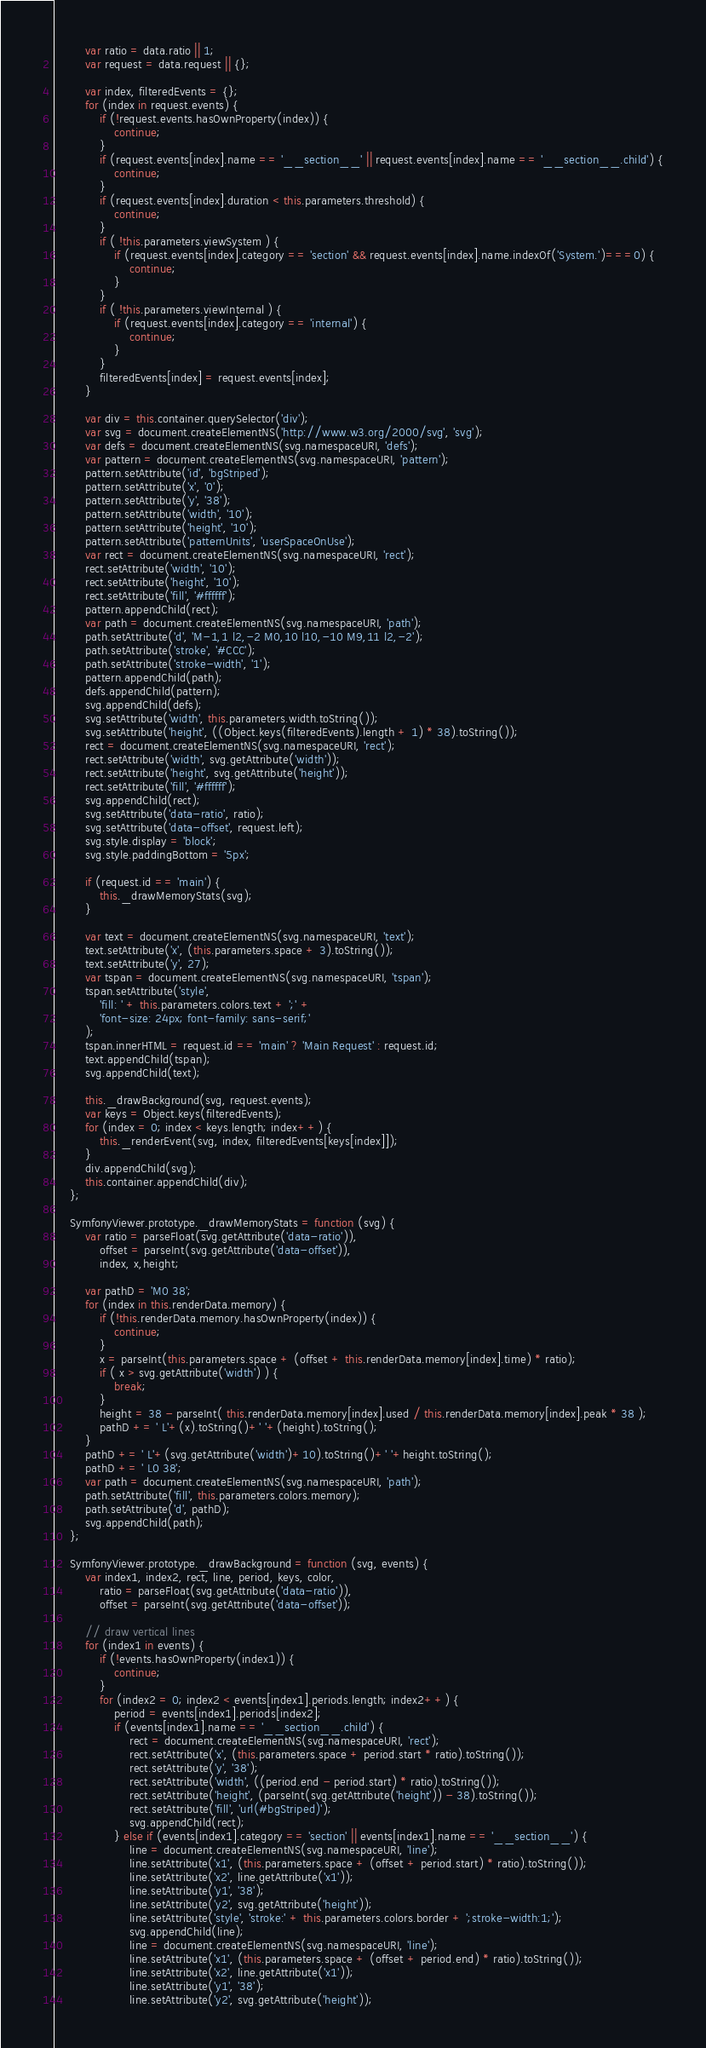Convert code to text. <code><loc_0><loc_0><loc_500><loc_500><_JavaScript_>        var ratio = data.ratio || 1;
        var request = data.request || {};

        var index, filteredEvents = {};
        for (index in request.events) {
            if (!request.events.hasOwnProperty(index)) {
                continue;
            }
            if (request.events[index].name == '__section__' || request.events[index].name == '__section__.child') {
                continue;
            }
            if (request.events[index].duration < this.parameters.threshold) {
                continue;
            }
            if ( !this.parameters.viewSystem ) {
                if (request.events[index].category == 'section' && request.events[index].name.indexOf('System.')===0) {
                    continue;
                }
            }
            if ( !this.parameters.viewInternal ) {
                if (request.events[index].category == 'internal') {
                    continue;
                }
            }
            filteredEvents[index] = request.events[index];
        }

        var div = this.container.querySelector('div');
        var svg = document.createElementNS('http://www.w3.org/2000/svg', 'svg');
        var defs = document.createElementNS(svg.namespaceURI, 'defs');
        var pattern = document.createElementNS(svg.namespaceURI, 'pattern');
        pattern.setAttribute('id', 'bgStriped');
        pattern.setAttribute('x', '0');
        pattern.setAttribute('y', '38');
        pattern.setAttribute('width', '10');
        pattern.setAttribute('height', '10');
        pattern.setAttribute('patternUnits', 'userSpaceOnUse');
        var rect = document.createElementNS(svg.namespaceURI, 'rect');
        rect.setAttribute('width', '10');
        rect.setAttribute('height', '10');
        rect.setAttribute('fill', '#ffffff');
        pattern.appendChild(rect);
        var path = document.createElementNS(svg.namespaceURI, 'path');
        path.setAttribute('d', 'M-1,1 l2,-2 M0,10 l10,-10 M9,11 l2,-2');
        path.setAttribute('stroke', '#CCC');
        path.setAttribute('stroke-width', '1');
        pattern.appendChild(path);
        defs.appendChild(pattern);
        svg.appendChild(defs);
        svg.setAttribute('width', this.parameters.width.toString());
        svg.setAttribute('height', ((Object.keys(filteredEvents).length + 1) * 38).toString());
        rect = document.createElementNS(svg.namespaceURI, 'rect');
        rect.setAttribute('width', svg.getAttribute('width'));
        rect.setAttribute('height', svg.getAttribute('height'));
        rect.setAttribute('fill', '#ffffff');
        svg.appendChild(rect);
        svg.setAttribute('data-ratio', ratio);
        svg.setAttribute('data-offset', request.left);
        svg.style.display = 'block';
        svg.style.paddingBottom = '5px';

        if (request.id == 'main') {
            this._drawMemoryStats(svg);
        }

        var text = document.createElementNS(svg.namespaceURI, 'text');
        text.setAttribute('x', (this.parameters.space + 3).toString());
        text.setAttribute('y', 27);
        var tspan = document.createElementNS(svg.namespaceURI, 'tspan');
        tspan.setAttribute('style',
            'fill: ' + this.parameters.colors.text + ';' +
            'font-size: 24px; font-family: sans-serif;'
        );
        tspan.innerHTML = request.id == 'main' ? 'Main Request' : request.id;
        text.appendChild(tspan);
        svg.appendChild(text);

        this._drawBackground(svg, request.events);
        var keys = Object.keys(filteredEvents);
        for (index = 0; index < keys.length; index++) {
            this._renderEvent(svg, index, filteredEvents[keys[index]]);
        }
        div.appendChild(svg);
        this.container.appendChild(div);
    };

    SymfonyViewer.prototype._drawMemoryStats = function (svg) {
        var ratio = parseFloat(svg.getAttribute('data-ratio')),
            offset = parseInt(svg.getAttribute('data-offset')),
            index, x,height;

        var pathD = 'M0 38';
        for (index in this.renderData.memory) {
            if (!this.renderData.memory.hasOwnProperty(index)) {
                continue;
            }
            x = parseInt(this.parameters.space + (offset + this.renderData.memory[index].time) * ratio);
            if ( x > svg.getAttribute('width') ) {
                break;
            }
            height = 38 - parseInt( this.renderData.memory[index].used / this.renderData.memory[index].peak * 38 );
            pathD += ' L'+(x).toString()+' '+(height).toString();
        }
        pathD += ' L'+(svg.getAttribute('width')+10).toString()+' '+height.toString();
        pathD += ' L0 38';
        var path = document.createElementNS(svg.namespaceURI, 'path');
        path.setAttribute('fill', this.parameters.colors.memory);
        path.setAttribute('d', pathD);
        svg.appendChild(path);
    };

    SymfonyViewer.prototype._drawBackground = function (svg, events) {
        var index1, index2, rect, line, period, keys, color,
            ratio = parseFloat(svg.getAttribute('data-ratio')),
            offset = parseInt(svg.getAttribute('data-offset'));

        // draw vertical lines
        for (index1 in events) {
            if (!events.hasOwnProperty(index1)) {
                continue;
            }
            for (index2 = 0; index2 < events[index1].periods.length; index2++) {
                period = events[index1].periods[index2];
                if (events[index1].name == '__section__.child') {
                    rect = document.createElementNS(svg.namespaceURI, 'rect');
                    rect.setAttribute('x', (this.parameters.space + period.start * ratio).toString());
                    rect.setAttribute('y', '38');
                    rect.setAttribute('width', ((period.end - period.start) * ratio).toString());
                    rect.setAttribute('height', (parseInt(svg.getAttribute('height')) - 38).toString());
                    rect.setAttribute('fill', 'url(#bgStriped)');
                    svg.appendChild(rect);
                } else if (events[index1].category == 'section' || events[index1].name == '__section__') {
                    line = document.createElementNS(svg.namespaceURI, 'line');
                    line.setAttribute('x1', (this.parameters.space + (offset + period.start) * ratio).toString());
                    line.setAttribute('x2', line.getAttribute('x1'));
                    line.setAttribute('y1', '38');
                    line.setAttribute('y2', svg.getAttribute('height'));
                    line.setAttribute('style', 'stroke:' + this.parameters.colors.border + ';stroke-width:1;');
                    svg.appendChild(line);
                    line = document.createElementNS(svg.namespaceURI, 'line');
                    line.setAttribute('x1', (this.parameters.space + (offset + period.end) * ratio).toString());
                    line.setAttribute('x2', line.getAttribute('x1'));
                    line.setAttribute('y1', '38');
                    line.setAttribute('y2', svg.getAttribute('height'));</code> 